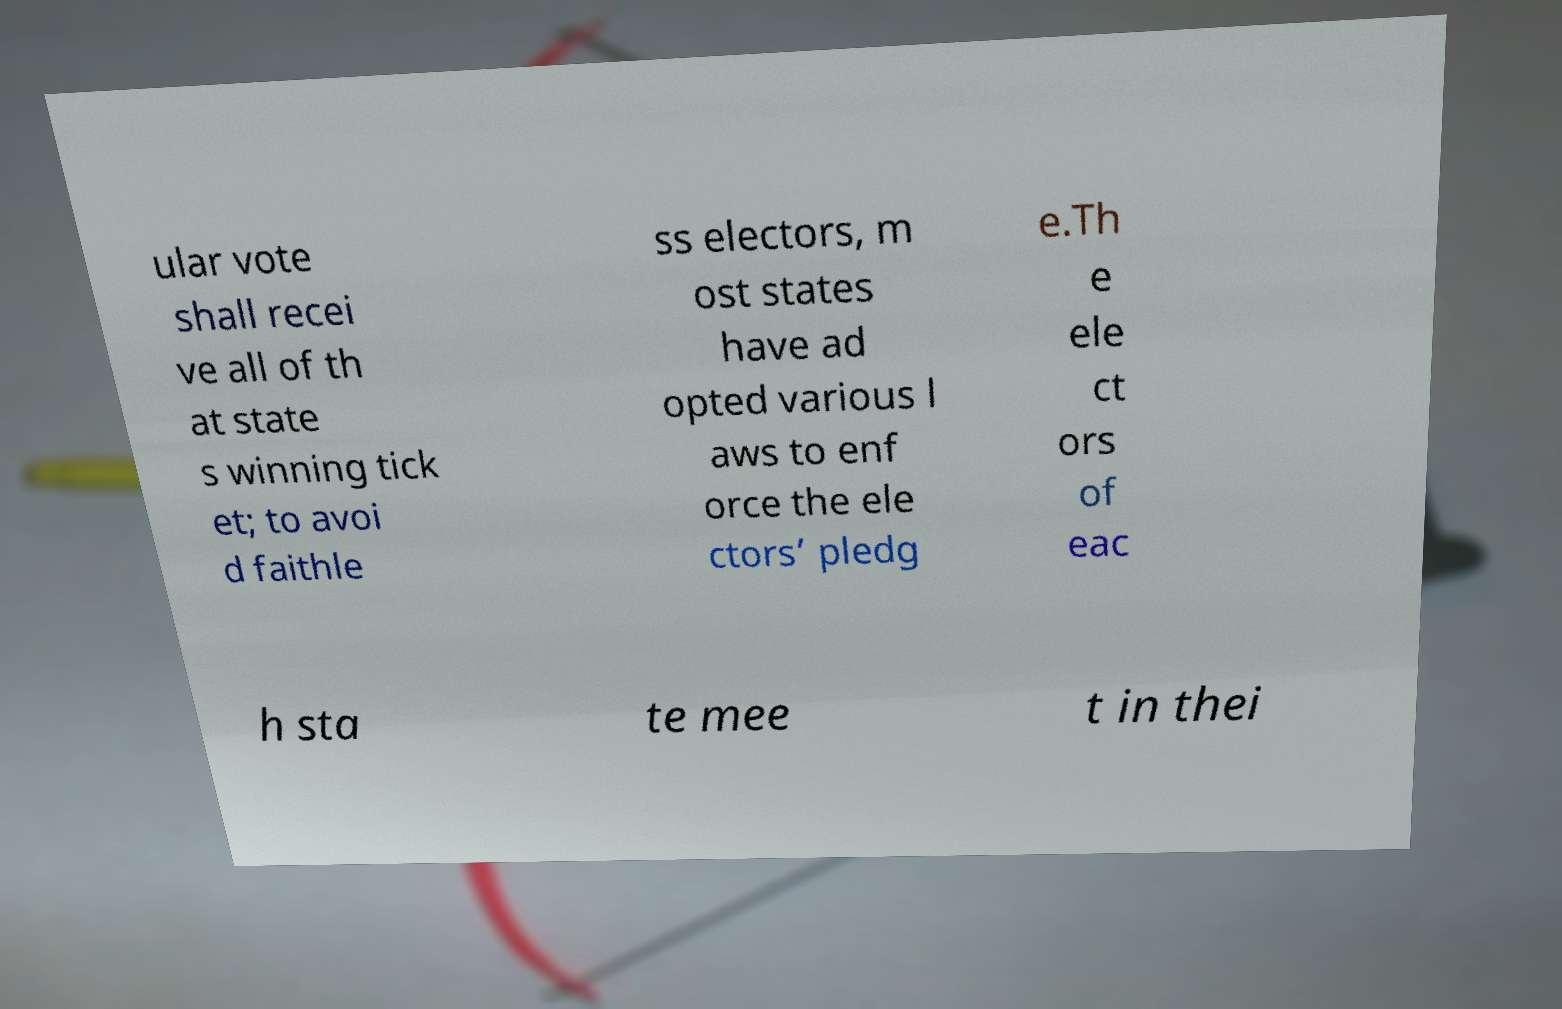What messages or text are displayed in this image? I need them in a readable, typed format. ular vote shall recei ve all of th at state s winning tick et; to avoi d faithle ss electors, m ost states have ad opted various l aws to enf orce the ele ctors’ pledg e.Th e ele ct ors of eac h sta te mee t in thei 